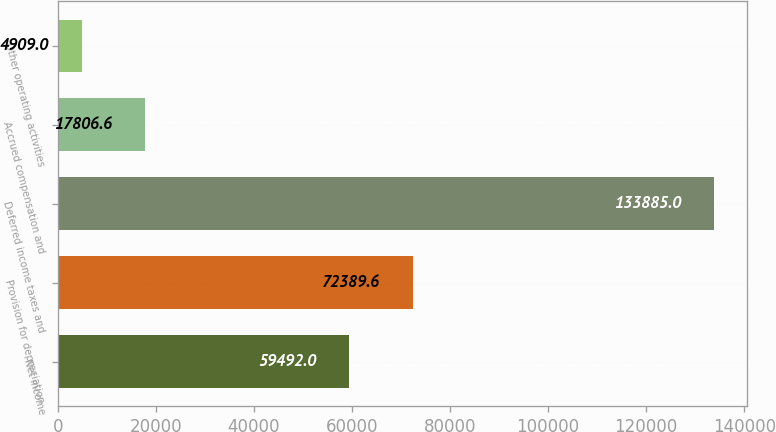Convert chart. <chart><loc_0><loc_0><loc_500><loc_500><bar_chart><fcel>Net income<fcel>Provision for depreciation<fcel>Deferred income taxes and<fcel>Accrued compensation and<fcel>Other operating activities<nl><fcel>59492<fcel>72389.6<fcel>133885<fcel>17806.6<fcel>4909<nl></chart> 